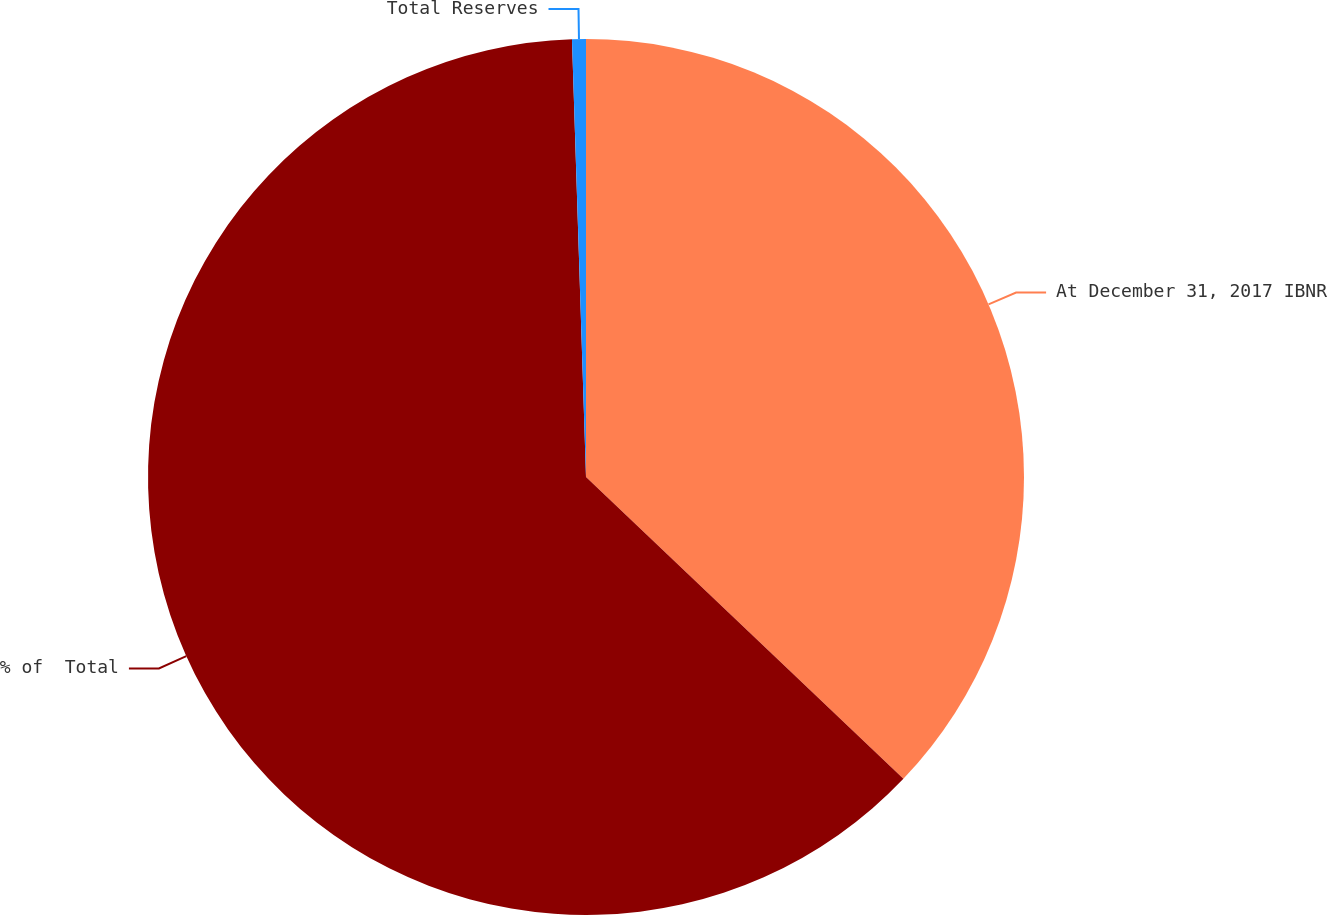Convert chart. <chart><loc_0><loc_0><loc_500><loc_500><pie_chart><fcel>At December 31, 2017 IBNR<fcel>% of  Total<fcel>Total Reserves<nl><fcel>37.1%<fcel>62.39%<fcel>0.51%<nl></chart> 